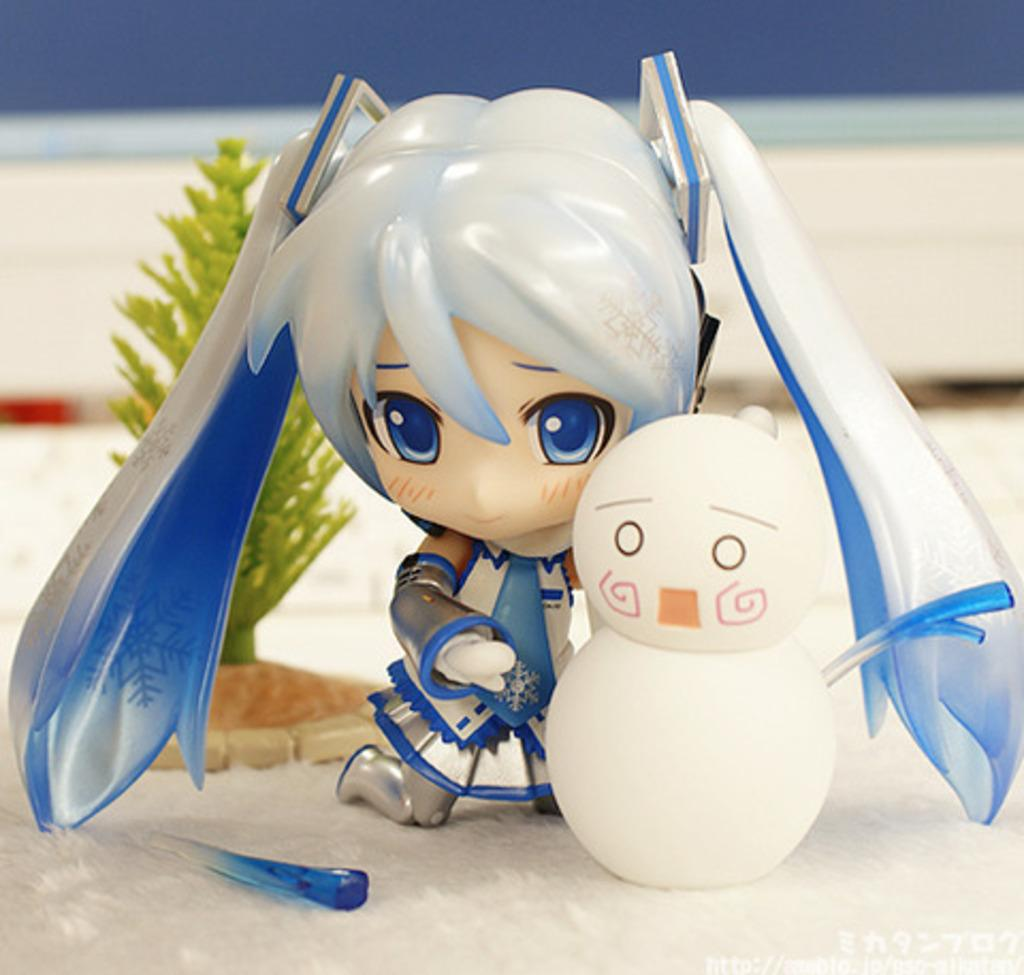What objects are present in the image? There are figurines in the image. Where are the figurines located? The figurines are placed on a surface. Are there any ants crawling on the figurines in the image? There is no mention of ants in the provided facts, so we cannot determine if there are any ants present in the image. 